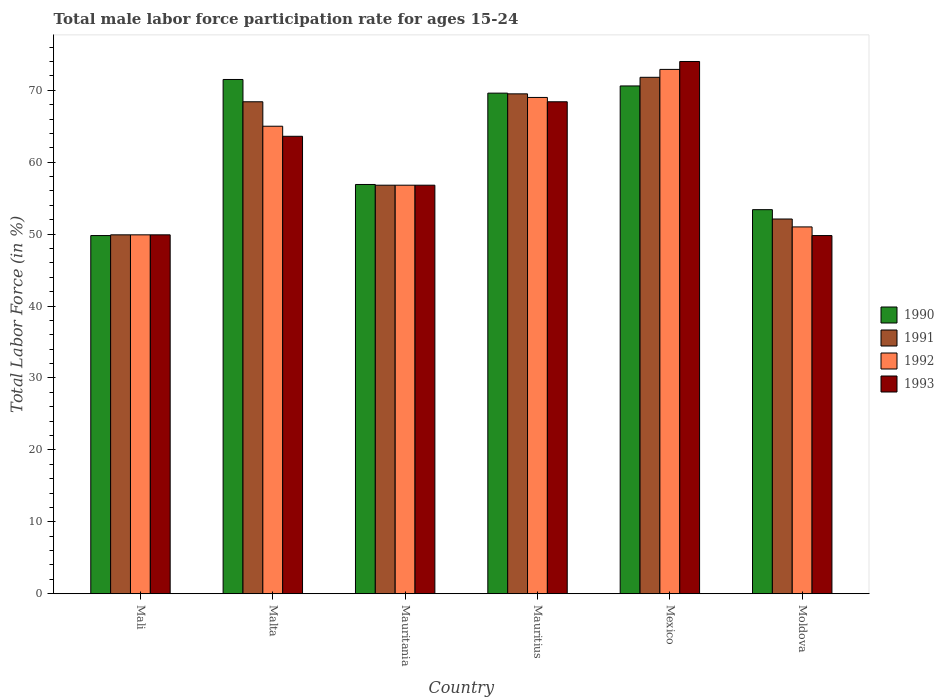What is the label of the 2nd group of bars from the left?
Your answer should be compact. Malta. In how many cases, is the number of bars for a given country not equal to the number of legend labels?
Offer a terse response. 0. What is the male labor force participation rate in 1993 in Moldova?
Your answer should be very brief. 49.8. Across all countries, what is the maximum male labor force participation rate in 1990?
Offer a terse response. 71.5. Across all countries, what is the minimum male labor force participation rate in 1992?
Your answer should be compact. 49.9. In which country was the male labor force participation rate in 1990 minimum?
Keep it short and to the point. Mali. What is the total male labor force participation rate in 1992 in the graph?
Your answer should be very brief. 364.6. What is the difference between the male labor force participation rate in 1992 in Mali and that in Malta?
Your answer should be very brief. -15.1. What is the difference between the male labor force participation rate in 1991 in Malta and the male labor force participation rate in 1992 in Moldova?
Give a very brief answer. 17.4. What is the average male labor force participation rate in 1990 per country?
Offer a very short reply. 61.97. What is the difference between the male labor force participation rate of/in 1990 and male labor force participation rate of/in 1992 in Mauritius?
Provide a succinct answer. 0.6. What is the ratio of the male labor force participation rate in 1993 in Mexico to that in Moldova?
Keep it short and to the point. 1.49. Is the difference between the male labor force participation rate in 1990 in Mali and Mauritania greater than the difference between the male labor force participation rate in 1992 in Mali and Mauritania?
Make the answer very short. No. What is the difference between the highest and the lowest male labor force participation rate in 1992?
Make the answer very short. 23. In how many countries, is the male labor force participation rate in 1993 greater than the average male labor force participation rate in 1993 taken over all countries?
Make the answer very short. 3. Is the sum of the male labor force participation rate in 1993 in Mauritania and Mexico greater than the maximum male labor force participation rate in 1991 across all countries?
Your answer should be very brief. Yes. Is it the case that in every country, the sum of the male labor force participation rate in 1993 and male labor force participation rate in 1992 is greater than the sum of male labor force participation rate in 1990 and male labor force participation rate in 1991?
Your answer should be very brief. No. What does the 3rd bar from the left in Mauritius represents?
Provide a succinct answer. 1992. Is it the case that in every country, the sum of the male labor force participation rate in 1990 and male labor force participation rate in 1993 is greater than the male labor force participation rate in 1992?
Provide a short and direct response. Yes. How many bars are there?
Give a very brief answer. 24. How many countries are there in the graph?
Your answer should be compact. 6. Are the values on the major ticks of Y-axis written in scientific E-notation?
Keep it short and to the point. No. Where does the legend appear in the graph?
Keep it short and to the point. Center right. What is the title of the graph?
Offer a very short reply. Total male labor force participation rate for ages 15-24. Does "1977" appear as one of the legend labels in the graph?
Your answer should be very brief. No. What is the label or title of the X-axis?
Keep it short and to the point. Country. What is the label or title of the Y-axis?
Offer a very short reply. Total Labor Force (in %). What is the Total Labor Force (in %) in 1990 in Mali?
Offer a terse response. 49.8. What is the Total Labor Force (in %) of 1991 in Mali?
Ensure brevity in your answer.  49.9. What is the Total Labor Force (in %) in 1992 in Mali?
Provide a succinct answer. 49.9. What is the Total Labor Force (in %) in 1993 in Mali?
Ensure brevity in your answer.  49.9. What is the Total Labor Force (in %) of 1990 in Malta?
Provide a succinct answer. 71.5. What is the Total Labor Force (in %) in 1991 in Malta?
Your response must be concise. 68.4. What is the Total Labor Force (in %) in 1993 in Malta?
Offer a terse response. 63.6. What is the Total Labor Force (in %) of 1990 in Mauritania?
Give a very brief answer. 56.9. What is the Total Labor Force (in %) in 1991 in Mauritania?
Offer a very short reply. 56.8. What is the Total Labor Force (in %) in 1992 in Mauritania?
Offer a terse response. 56.8. What is the Total Labor Force (in %) in 1993 in Mauritania?
Provide a succinct answer. 56.8. What is the Total Labor Force (in %) in 1990 in Mauritius?
Your answer should be very brief. 69.6. What is the Total Labor Force (in %) in 1991 in Mauritius?
Your answer should be compact. 69.5. What is the Total Labor Force (in %) in 1992 in Mauritius?
Offer a very short reply. 69. What is the Total Labor Force (in %) of 1993 in Mauritius?
Keep it short and to the point. 68.4. What is the Total Labor Force (in %) of 1990 in Mexico?
Offer a terse response. 70.6. What is the Total Labor Force (in %) of 1991 in Mexico?
Provide a succinct answer. 71.8. What is the Total Labor Force (in %) of 1992 in Mexico?
Offer a very short reply. 72.9. What is the Total Labor Force (in %) in 1990 in Moldova?
Provide a succinct answer. 53.4. What is the Total Labor Force (in %) in 1991 in Moldova?
Offer a terse response. 52.1. What is the Total Labor Force (in %) of 1993 in Moldova?
Give a very brief answer. 49.8. Across all countries, what is the maximum Total Labor Force (in %) in 1990?
Your answer should be compact. 71.5. Across all countries, what is the maximum Total Labor Force (in %) of 1991?
Give a very brief answer. 71.8. Across all countries, what is the maximum Total Labor Force (in %) in 1992?
Your response must be concise. 72.9. Across all countries, what is the minimum Total Labor Force (in %) of 1990?
Your answer should be very brief. 49.8. Across all countries, what is the minimum Total Labor Force (in %) of 1991?
Ensure brevity in your answer.  49.9. Across all countries, what is the minimum Total Labor Force (in %) in 1992?
Your response must be concise. 49.9. Across all countries, what is the minimum Total Labor Force (in %) in 1993?
Give a very brief answer. 49.8. What is the total Total Labor Force (in %) in 1990 in the graph?
Your answer should be very brief. 371.8. What is the total Total Labor Force (in %) in 1991 in the graph?
Provide a short and direct response. 368.5. What is the total Total Labor Force (in %) of 1992 in the graph?
Make the answer very short. 364.6. What is the total Total Labor Force (in %) of 1993 in the graph?
Provide a short and direct response. 362.5. What is the difference between the Total Labor Force (in %) of 1990 in Mali and that in Malta?
Ensure brevity in your answer.  -21.7. What is the difference between the Total Labor Force (in %) in 1991 in Mali and that in Malta?
Give a very brief answer. -18.5. What is the difference between the Total Labor Force (in %) of 1992 in Mali and that in Malta?
Keep it short and to the point. -15.1. What is the difference between the Total Labor Force (in %) in 1993 in Mali and that in Malta?
Ensure brevity in your answer.  -13.7. What is the difference between the Total Labor Force (in %) in 1990 in Mali and that in Mauritania?
Your answer should be compact. -7.1. What is the difference between the Total Labor Force (in %) in 1992 in Mali and that in Mauritania?
Keep it short and to the point. -6.9. What is the difference between the Total Labor Force (in %) in 1990 in Mali and that in Mauritius?
Your response must be concise. -19.8. What is the difference between the Total Labor Force (in %) in 1991 in Mali and that in Mauritius?
Keep it short and to the point. -19.6. What is the difference between the Total Labor Force (in %) in 1992 in Mali and that in Mauritius?
Give a very brief answer. -19.1. What is the difference between the Total Labor Force (in %) in 1993 in Mali and that in Mauritius?
Make the answer very short. -18.5. What is the difference between the Total Labor Force (in %) in 1990 in Mali and that in Mexico?
Offer a terse response. -20.8. What is the difference between the Total Labor Force (in %) in 1991 in Mali and that in Mexico?
Offer a terse response. -21.9. What is the difference between the Total Labor Force (in %) in 1992 in Mali and that in Mexico?
Offer a terse response. -23. What is the difference between the Total Labor Force (in %) of 1993 in Mali and that in Mexico?
Ensure brevity in your answer.  -24.1. What is the difference between the Total Labor Force (in %) in 1991 in Malta and that in Mauritania?
Your answer should be very brief. 11.6. What is the difference between the Total Labor Force (in %) of 1990 in Malta and that in Mauritius?
Your answer should be compact. 1.9. What is the difference between the Total Labor Force (in %) of 1992 in Malta and that in Mauritius?
Make the answer very short. -4. What is the difference between the Total Labor Force (in %) of 1993 in Malta and that in Mauritius?
Give a very brief answer. -4.8. What is the difference between the Total Labor Force (in %) of 1991 in Malta and that in Mexico?
Your answer should be very brief. -3.4. What is the difference between the Total Labor Force (in %) of 1990 in Malta and that in Moldova?
Keep it short and to the point. 18.1. What is the difference between the Total Labor Force (in %) in 1991 in Malta and that in Moldova?
Give a very brief answer. 16.3. What is the difference between the Total Labor Force (in %) of 1992 in Malta and that in Moldova?
Your answer should be compact. 14. What is the difference between the Total Labor Force (in %) in 1993 in Malta and that in Moldova?
Make the answer very short. 13.8. What is the difference between the Total Labor Force (in %) of 1992 in Mauritania and that in Mauritius?
Keep it short and to the point. -12.2. What is the difference between the Total Labor Force (in %) in 1990 in Mauritania and that in Mexico?
Give a very brief answer. -13.7. What is the difference between the Total Labor Force (in %) of 1992 in Mauritania and that in Mexico?
Offer a very short reply. -16.1. What is the difference between the Total Labor Force (in %) in 1993 in Mauritania and that in Mexico?
Your answer should be very brief. -17.2. What is the difference between the Total Labor Force (in %) in 1990 in Mauritania and that in Moldova?
Provide a short and direct response. 3.5. What is the difference between the Total Labor Force (in %) of 1991 in Mauritania and that in Moldova?
Your response must be concise. 4.7. What is the difference between the Total Labor Force (in %) of 1992 in Mauritania and that in Moldova?
Ensure brevity in your answer.  5.8. What is the difference between the Total Labor Force (in %) in 1993 in Mauritania and that in Moldova?
Your response must be concise. 7. What is the difference between the Total Labor Force (in %) of 1990 in Mauritius and that in Mexico?
Provide a succinct answer. -1. What is the difference between the Total Labor Force (in %) of 1992 in Mauritius and that in Mexico?
Your answer should be compact. -3.9. What is the difference between the Total Labor Force (in %) of 1990 in Mauritius and that in Moldova?
Your answer should be very brief. 16.2. What is the difference between the Total Labor Force (in %) of 1991 in Mauritius and that in Moldova?
Make the answer very short. 17.4. What is the difference between the Total Labor Force (in %) in 1992 in Mauritius and that in Moldova?
Your answer should be compact. 18. What is the difference between the Total Labor Force (in %) of 1990 in Mexico and that in Moldova?
Your answer should be very brief. 17.2. What is the difference between the Total Labor Force (in %) of 1992 in Mexico and that in Moldova?
Keep it short and to the point. 21.9. What is the difference between the Total Labor Force (in %) in 1993 in Mexico and that in Moldova?
Offer a very short reply. 24.2. What is the difference between the Total Labor Force (in %) of 1990 in Mali and the Total Labor Force (in %) of 1991 in Malta?
Provide a short and direct response. -18.6. What is the difference between the Total Labor Force (in %) of 1990 in Mali and the Total Labor Force (in %) of 1992 in Malta?
Make the answer very short. -15.2. What is the difference between the Total Labor Force (in %) in 1990 in Mali and the Total Labor Force (in %) in 1993 in Malta?
Provide a short and direct response. -13.8. What is the difference between the Total Labor Force (in %) in 1991 in Mali and the Total Labor Force (in %) in 1992 in Malta?
Ensure brevity in your answer.  -15.1. What is the difference between the Total Labor Force (in %) in 1991 in Mali and the Total Labor Force (in %) in 1993 in Malta?
Provide a short and direct response. -13.7. What is the difference between the Total Labor Force (in %) of 1992 in Mali and the Total Labor Force (in %) of 1993 in Malta?
Offer a very short reply. -13.7. What is the difference between the Total Labor Force (in %) of 1990 in Mali and the Total Labor Force (in %) of 1991 in Mauritania?
Offer a terse response. -7. What is the difference between the Total Labor Force (in %) of 1991 in Mali and the Total Labor Force (in %) of 1992 in Mauritania?
Keep it short and to the point. -6.9. What is the difference between the Total Labor Force (in %) in 1991 in Mali and the Total Labor Force (in %) in 1993 in Mauritania?
Keep it short and to the point. -6.9. What is the difference between the Total Labor Force (in %) of 1990 in Mali and the Total Labor Force (in %) of 1991 in Mauritius?
Your answer should be compact. -19.7. What is the difference between the Total Labor Force (in %) in 1990 in Mali and the Total Labor Force (in %) in 1992 in Mauritius?
Your answer should be very brief. -19.2. What is the difference between the Total Labor Force (in %) of 1990 in Mali and the Total Labor Force (in %) of 1993 in Mauritius?
Provide a succinct answer. -18.6. What is the difference between the Total Labor Force (in %) in 1991 in Mali and the Total Labor Force (in %) in 1992 in Mauritius?
Ensure brevity in your answer.  -19.1. What is the difference between the Total Labor Force (in %) of 1991 in Mali and the Total Labor Force (in %) of 1993 in Mauritius?
Your answer should be compact. -18.5. What is the difference between the Total Labor Force (in %) of 1992 in Mali and the Total Labor Force (in %) of 1993 in Mauritius?
Offer a very short reply. -18.5. What is the difference between the Total Labor Force (in %) of 1990 in Mali and the Total Labor Force (in %) of 1992 in Mexico?
Provide a short and direct response. -23.1. What is the difference between the Total Labor Force (in %) in 1990 in Mali and the Total Labor Force (in %) in 1993 in Mexico?
Offer a very short reply. -24.2. What is the difference between the Total Labor Force (in %) of 1991 in Mali and the Total Labor Force (in %) of 1992 in Mexico?
Provide a succinct answer. -23. What is the difference between the Total Labor Force (in %) in 1991 in Mali and the Total Labor Force (in %) in 1993 in Mexico?
Offer a very short reply. -24.1. What is the difference between the Total Labor Force (in %) of 1992 in Mali and the Total Labor Force (in %) of 1993 in Mexico?
Offer a terse response. -24.1. What is the difference between the Total Labor Force (in %) of 1990 in Mali and the Total Labor Force (in %) of 1991 in Moldova?
Your response must be concise. -2.3. What is the difference between the Total Labor Force (in %) in 1990 in Mali and the Total Labor Force (in %) in 1992 in Moldova?
Your response must be concise. -1.2. What is the difference between the Total Labor Force (in %) in 1990 in Mali and the Total Labor Force (in %) in 1993 in Moldova?
Ensure brevity in your answer.  0. What is the difference between the Total Labor Force (in %) of 1991 in Mali and the Total Labor Force (in %) of 1993 in Moldova?
Your answer should be compact. 0.1. What is the difference between the Total Labor Force (in %) of 1990 in Malta and the Total Labor Force (in %) of 1991 in Mauritania?
Ensure brevity in your answer.  14.7. What is the difference between the Total Labor Force (in %) in 1990 in Malta and the Total Labor Force (in %) in 1992 in Mauritania?
Provide a short and direct response. 14.7. What is the difference between the Total Labor Force (in %) in 1990 in Malta and the Total Labor Force (in %) in 1993 in Mauritania?
Give a very brief answer. 14.7. What is the difference between the Total Labor Force (in %) of 1991 in Malta and the Total Labor Force (in %) of 1993 in Mauritania?
Make the answer very short. 11.6. What is the difference between the Total Labor Force (in %) in 1990 in Malta and the Total Labor Force (in %) in 1991 in Mauritius?
Offer a terse response. 2. What is the difference between the Total Labor Force (in %) of 1990 in Malta and the Total Labor Force (in %) of 1992 in Mauritius?
Provide a short and direct response. 2.5. What is the difference between the Total Labor Force (in %) of 1990 in Malta and the Total Labor Force (in %) of 1993 in Mauritius?
Keep it short and to the point. 3.1. What is the difference between the Total Labor Force (in %) in 1990 in Malta and the Total Labor Force (in %) in 1991 in Mexico?
Keep it short and to the point. -0.3. What is the difference between the Total Labor Force (in %) in 1990 in Malta and the Total Labor Force (in %) in 1992 in Mexico?
Provide a succinct answer. -1.4. What is the difference between the Total Labor Force (in %) of 1990 in Malta and the Total Labor Force (in %) of 1993 in Mexico?
Offer a terse response. -2.5. What is the difference between the Total Labor Force (in %) of 1991 in Malta and the Total Labor Force (in %) of 1993 in Mexico?
Give a very brief answer. -5.6. What is the difference between the Total Labor Force (in %) of 1992 in Malta and the Total Labor Force (in %) of 1993 in Mexico?
Give a very brief answer. -9. What is the difference between the Total Labor Force (in %) in 1990 in Malta and the Total Labor Force (in %) in 1991 in Moldova?
Make the answer very short. 19.4. What is the difference between the Total Labor Force (in %) of 1990 in Malta and the Total Labor Force (in %) of 1992 in Moldova?
Offer a terse response. 20.5. What is the difference between the Total Labor Force (in %) of 1990 in Malta and the Total Labor Force (in %) of 1993 in Moldova?
Provide a succinct answer. 21.7. What is the difference between the Total Labor Force (in %) in 1991 in Malta and the Total Labor Force (in %) in 1992 in Moldova?
Give a very brief answer. 17.4. What is the difference between the Total Labor Force (in %) of 1991 in Malta and the Total Labor Force (in %) of 1993 in Moldova?
Ensure brevity in your answer.  18.6. What is the difference between the Total Labor Force (in %) of 1992 in Malta and the Total Labor Force (in %) of 1993 in Moldova?
Provide a succinct answer. 15.2. What is the difference between the Total Labor Force (in %) in 1990 in Mauritania and the Total Labor Force (in %) in 1992 in Mauritius?
Provide a succinct answer. -12.1. What is the difference between the Total Labor Force (in %) of 1991 in Mauritania and the Total Labor Force (in %) of 1992 in Mauritius?
Keep it short and to the point. -12.2. What is the difference between the Total Labor Force (in %) in 1992 in Mauritania and the Total Labor Force (in %) in 1993 in Mauritius?
Your response must be concise. -11.6. What is the difference between the Total Labor Force (in %) in 1990 in Mauritania and the Total Labor Force (in %) in 1991 in Mexico?
Your answer should be compact. -14.9. What is the difference between the Total Labor Force (in %) of 1990 in Mauritania and the Total Labor Force (in %) of 1993 in Mexico?
Provide a short and direct response. -17.1. What is the difference between the Total Labor Force (in %) in 1991 in Mauritania and the Total Labor Force (in %) in 1992 in Mexico?
Keep it short and to the point. -16.1. What is the difference between the Total Labor Force (in %) in 1991 in Mauritania and the Total Labor Force (in %) in 1993 in Mexico?
Your answer should be compact. -17.2. What is the difference between the Total Labor Force (in %) of 1992 in Mauritania and the Total Labor Force (in %) of 1993 in Mexico?
Your response must be concise. -17.2. What is the difference between the Total Labor Force (in %) of 1990 in Mauritania and the Total Labor Force (in %) of 1991 in Moldova?
Make the answer very short. 4.8. What is the difference between the Total Labor Force (in %) of 1990 in Mauritania and the Total Labor Force (in %) of 1992 in Moldova?
Your answer should be very brief. 5.9. What is the difference between the Total Labor Force (in %) in 1991 in Mauritania and the Total Labor Force (in %) in 1992 in Moldova?
Your answer should be very brief. 5.8. What is the difference between the Total Labor Force (in %) of 1991 in Mauritania and the Total Labor Force (in %) of 1993 in Moldova?
Offer a very short reply. 7. What is the difference between the Total Labor Force (in %) of 1992 in Mauritania and the Total Labor Force (in %) of 1993 in Moldova?
Ensure brevity in your answer.  7. What is the difference between the Total Labor Force (in %) of 1990 in Mauritius and the Total Labor Force (in %) of 1993 in Mexico?
Provide a succinct answer. -4.4. What is the difference between the Total Labor Force (in %) in 1991 in Mauritius and the Total Labor Force (in %) in 1992 in Mexico?
Offer a terse response. -3.4. What is the difference between the Total Labor Force (in %) of 1990 in Mauritius and the Total Labor Force (in %) of 1993 in Moldova?
Ensure brevity in your answer.  19.8. What is the difference between the Total Labor Force (in %) in 1991 in Mauritius and the Total Labor Force (in %) in 1992 in Moldova?
Your response must be concise. 18.5. What is the difference between the Total Labor Force (in %) in 1990 in Mexico and the Total Labor Force (in %) in 1992 in Moldova?
Ensure brevity in your answer.  19.6. What is the difference between the Total Labor Force (in %) in 1990 in Mexico and the Total Labor Force (in %) in 1993 in Moldova?
Provide a succinct answer. 20.8. What is the difference between the Total Labor Force (in %) in 1991 in Mexico and the Total Labor Force (in %) in 1992 in Moldova?
Make the answer very short. 20.8. What is the difference between the Total Labor Force (in %) of 1991 in Mexico and the Total Labor Force (in %) of 1993 in Moldova?
Give a very brief answer. 22. What is the difference between the Total Labor Force (in %) in 1992 in Mexico and the Total Labor Force (in %) in 1993 in Moldova?
Your answer should be compact. 23.1. What is the average Total Labor Force (in %) in 1990 per country?
Your answer should be very brief. 61.97. What is the average Total Labor Force (in %) of 1991 per country?
Provide a short and direct response. 61.42. What is the average Total Labor Force (in %) of 1992 per country?
Provide a short and direct response. 60.77. What is the average Total Labor Force (in %) of 1993 per country?
Give a very brief answer. 60.42. What is the difference between the Total Labor Force (in %) in 1992 and Total Labor Force (in %) in 1993 in Mali?
Ensure brevity in your answer.  0. What is the difference between the Total Labor Force (in %) of 1990 and Total Labor Force (in %) of 1991 in Malta?
Give a very brief answer. 3.1. What is the difference between the Total Labor Force (in %) in 1992 and Total Labor Force (in %) in 1993 in Malta?
Make the answer very short. 1.4. What is the difference between the Total Labor Force (in %) in 1990 and Total Labor Force (in %) in 1991 in Mauritania?
Provide a succinct answer. 0.1. What is the difference between the Total Labor Force (in %) of 1990 and Total Labor Force (in %) of 1991 in Mauritius?
Give a very brief answer. 0.1. What is the difference between the Total Labor Force (in %) of 1990 and Total Labor Force (in %) of 1993 in Mauritius?
Offer a terse response. 1.2. What is the difference between the Total Labor Force (in %) of 1991 and Total Labor Force (in %) of 1993 in Mauritius?
Provide a succinct answer. 1.1. What is the difference between the Total Labor Force (in %) in 1990 and Total Labor Force (in %) in 1991 in Mexico?
Ensure brevity in your answer.  -1.2. What is the difference between the Total Labor Force (in %) of 1990 and Total Labor Force (in %) of 1992 in Mexico?
Keep it short and to the point. -2.3. What is the difference between the Total Labor Force (in %) of 1991 and Total Labor Force (in %) of 1993 in Mexico?
Offer a terse response. -2.2. What is the difference between the Total Labor Force (in %) in 1992 and Total Labor Force (in %) in 1993 in Mexico?
Provide a succinct answer. -1.1. What is the difference between the Total Labor Force (in %) in 1991 and Total Labor Force (in %) in 1992 in Moldova?
Offer a very short reply. 1.1. What is the difference between the Total Labor Force (in %) of 1992 and Total Labor Force (in %) of 1993 in Moldova?
Your answer should be very brief. 1.2. What is the ratio of the Total Labor Force (in %) of 1990 in Mali to that in Malta?
Offer a terse response. 0.7. What is the ratio of the Total Labor Force (in %) in 1991 in Mali to that in Malta?
Your answer should be compact. 0.73. What is the ratio of the Total Labor Force (in %) of 1992 in Mali to that in Malta?
Your answer should be compact. 0.77. What is the ratio of the Total Labor Force (in %) of 1993 in Mali to that in Malta?
Your answer should be compact. 0.78. What is the ratio of the Total Labor Force (in %) in 1990 in Mali to that in Mauritania?
Provide a short and direct response. 0.88. What is the ratio of the Total Labor Force (in %) of 1991 in Mali to that in Mauritania?
Give a very brief answer. 0.88. What is the ratio of the Total Labor Force (in %) of 1992 in Mali to that in Mauritania?
Offer a very short reply. 0.88. What is the ratio of the Total Labor Force (in %) of 1993 in Mali to that in Mauritania?
Ensure brevity in your answer.  0.88. What is the ratio of the Total Labor Force (in %) in 1990 in Mali to that in Mauritius?
Provide a short and direct response. 0.72. What is the ratio of the Total Labor Force (in %) of 1991 in Mali to that in Mauritius?
Your response must be concise. 0.72. What is the ratio of the Total Labor Force (in %) in 1992 in Mali to that in Mauritius?
Your answer should be compact. 0.72. What is the ratio of the Total Labor Force (in %) of 1993 in Mali to that in Mauritius?
Ensure brevity in your answer.  0.73. What is the ratio of the Total Labor Force (in %) in 1990 in Mali to that in Mexico?
Your answer should be very brief. 0.71. What is the ratio of the Total Labor Force (in %) of 1991 in Mali to that in Mexico?
Your response must be concise. 0.69. What is the ratio of the Total Labor Force (in %) in 1992 in Mali to that in Mexico?
Offer a terse response. 0.68. What is the ratio of the Total Labor Force (in %) of 1993 in Mali to that in Mexico?
Offer a terse response. 0.67. What is the ratio of the Total Labor Force (in %) of 1990 in Mali to that in Moldova?
Make the answer very short. 0.93. What is the ratio of the Total Labor Force (in %) of 1991 in Mali to that in Moldova?
Make the answer very short. 0.96. What is the ratio of the Total Labor Force (in %) in 1992 in Mali to that in Moldova?
Your response must be concise. 0.98. What is the ratio of the Total Labor Force (in %) in 1993 in Mali to that in Moldova?
Ensure brevity in your answer.  1. What is the ratio of the Total Labor Force (in %) in 1990 in Malta to that in Mauritania?
Offer a very short reply. 1.26. What is the ratio of the Total Labor Force (in %) of 1991 in Malta to that in Mauritania?
Your answer should be compact. 1.2. What is the ratio of the Total Labor Force (in %) of 1992 in Malta to that in Mauritania?
Your response must be concise. 1.14. What is the ratio of the Total Labor Force (in %) of 1993 in Malta to that in Mauritania?
Offer a very short reply. 1.12. What is the ratio of the Total Labor Force (in %) of 1990 in Malta to that in Mauritius?
Your response must be concise. 1.03. What is the ratio of the Total Labor Force (in %) in 1991 in Malta to that in Mauritius?
Your answer should be very brief. 0.98. What is the ratio of the Total Labor Force (in %) in 1992 in Malta to that in Mauritius?
Offer a terse response. 0.94. What is the ratio of the Total Labor Force (in %) in 1993 in Malta to that in Mauritius?
Provide a short and direct response. 0.93. What is the ratio of the Total Labor Force (in %) of 1990 in Malta to that in Mexico?
Your answer should be very brief. 1.01. What is the ratio of the Total Labor Force (in %) of 1991 in Malta to that in Mexico?
Give a very brief answer. 0.95. What is the ratio of the Total Labor Force (in %) of 1992 in Malta to that in Mexico?
Your answer should be very brief. 0.89. What is the ratio of the Total Labor Force (in %) of 1993 in Malta to that in Mexico?
Offer a very short reply. 0.86. What is the ratio of the Total Labor Force (in %) in 1990 in Malta to that in Moldova?
Offer a terse response. 1.34. What is the ratio of the Total Labor Force (in %) of 1991 in Malta to that in Moldova?
Offer a terse response. 1.31. What is the ratio of the Total Labor Force (in %) of 1992 in Malta to that in Moldova?
Offer a terse response. 1.27. What is the ratio of the Total Labor Force (in %) in 1993 in Malta to that in Moldova?
Provide a succinct answer. 1.28. What is the ratio of the Total Labor Force (in %) in 1990 in Mauritania to that in Mauritius?
Make the answer very short. 0.82. What is the ratio of the Total Labor Force (in %) of 1991 in Mauritania to that in Mauritius?
Give a very brief answer. 0.82. What is the ratio of the Total Labor Force (in %) of 1992 in Mauritania to that in Mauritius?
Make the answer very short. 0.82. What is the ratio of the Total Labor Force (in %) of 1993 in Mauritania to that in Mauritius?
Provide a short and direct response. 0.83. What is the ratio of the Total Labor Force (in %) in 1990 in Mauritania to that in Mexico?
Provide a short and direct response. 0.81. What is the ratio of the Total Labor Force (in %) of 1991 in Mauritania to that in Mexico?
Make the answer very short. 0.79. What is the ratio of the Total Labor Force (in %) of 1992 in Mauritania to that in Mexico?
Provide a short and direct response. 0.78. What is the ratio of the Total Labor Force (in %) of 1993 in Mauritania to that in Mexico?
Ensure brevity in your answer.  0.77. What is the ratio of the Total Labor Force (in %) of 1990 in Mauritania to that in Moldova?
Offer a very short reply. 1.07. What is the ratio of the Total Labor Force (in %) of 1991 in Mauritania to that in Moldova?
Your answer should be compact. 1.09. What is the ratio of the Total Labor Force (in %) in 1992 in Mauritania to that in Moldova?
Offer a terse response. 1.11. What is the ratio of the Total Labor Force (in %) in 1993 in Mauritania to that in Moldova?
Make the answer very short. 1.14. What is the ratio of the Total Labor Force (in %) in 1990 in Mauritius to that in Mexico?
Offer a terse response. 0.99. What is the ratio of the Total Labor Force (in %) in 1992 in Mauritius to that in Mexico?
Your answer should be compact. 0.95. What is the ratio of the Total Labor Force (in %) in 1993 in Mauritius to that in Mexico?
Offer a very short reply. 0.92. What is the ratio of the Total Labor Force (in %) of 1990 in Mauritius to that in Moldova?
Keep it short and to the point. 1.3. What is the ratio of the Total Labor Force (in %) in 1991 in Mauritius to that in Moldova?
Offer a terse response. 1.33. What is the ratio of the Total Labor Force (in %) of 1992 in Mauritius to that in Moldova?
Provide a short and direct response. 1.35. What is the ratio of the Total Labor Force (in %) in 1993 in Mauritius to that in Moldova?
Your answer should be compact. 1.37. What is the ratio of the Total Labor Force (in %) in 1990 in Mexico to that in Moldova?
Provide a succinct answer. 1.32. What is the ratio of the Total Labor Force (in %) in 1991 in Mexico to that in Moldova?
Your response must be concise. 1.38. What is the ratio of the Total Labor Force (in %) in 1992 in Mexico to that in Moldova?
Give a very brief answer. 1.43. What is the ratio of the Total Labor Force (in %) of 1993 in Mexico to that in Moldova?
Offer a very short reply. 1.49. What is the difference between the highest and the second highest Total Labor Force (in %) of 1990?
Your response must be concise. 0.9. What is the difference between the highest and the second highest Total Labor Force (in %) of 1993?
Give a very brief answer. 5.6. What is the difference between the highest and the lowest Total Labor Force (in %) of 1990?
Provide a short and direct response. 21.7. What is the difference between the highest and the lowest Total Labor Force (in %) of 1991?
Ensure brevity in your answer.  21.9. What is the difference between the highest and the lowest Total Labor Force (in %) of 1993?
Give a very brief answer. 24.2. 